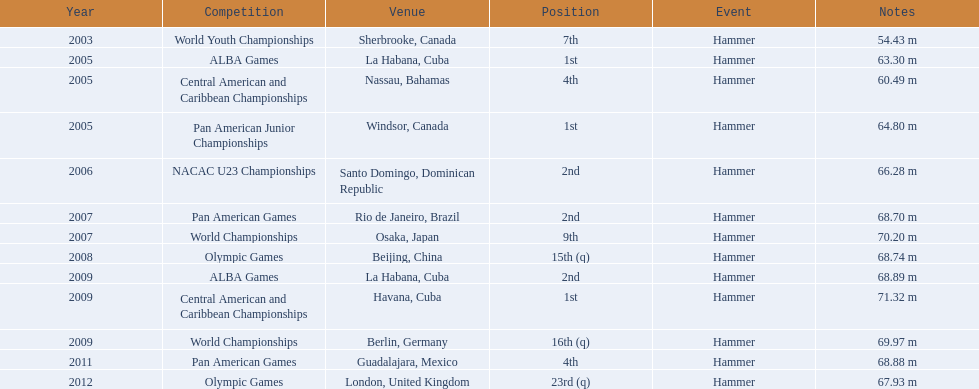Does the number of arasay thondike's tournament wins in 1st place exceed or fall short of four? Less. 